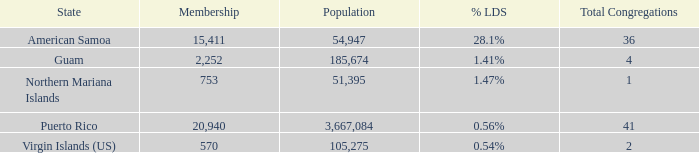What is Population, when Total Congregations is less than 4, and when % LDS is 0.54%? 105275.0. 